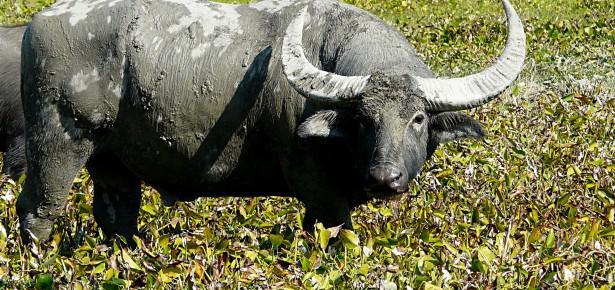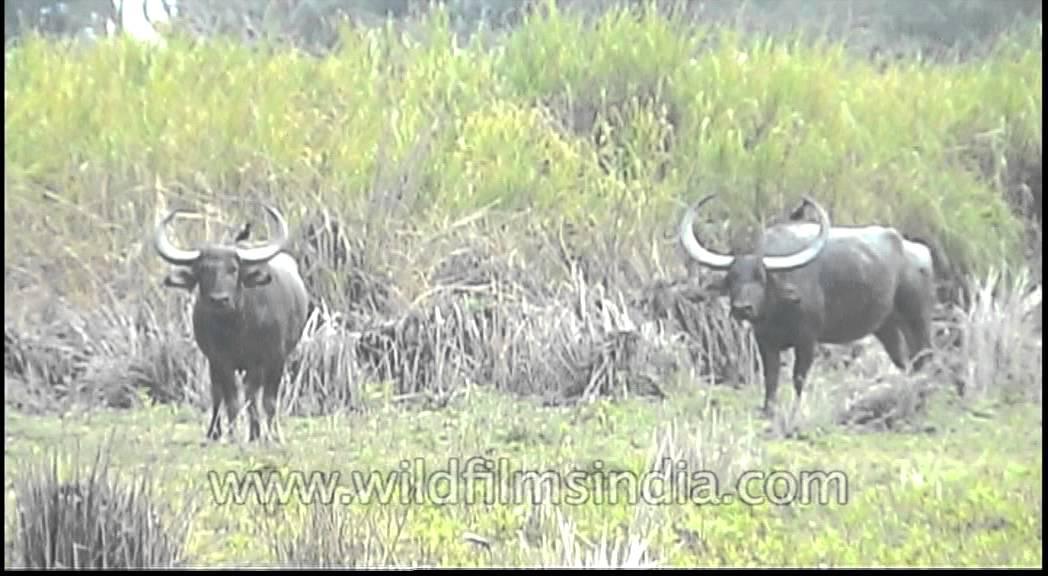The first image is the image on the left, the second image is the image on the right. Examine the images to the left and right. Is the description "Left image shows water buffalo upright in water." accurate? Answer yes or no. No. The first image is the image on the left, the second image is the image on the right. Given the left and right images, does the statement "At least one water buffalo is standing in water." hold true? Answer yes or no. No. 